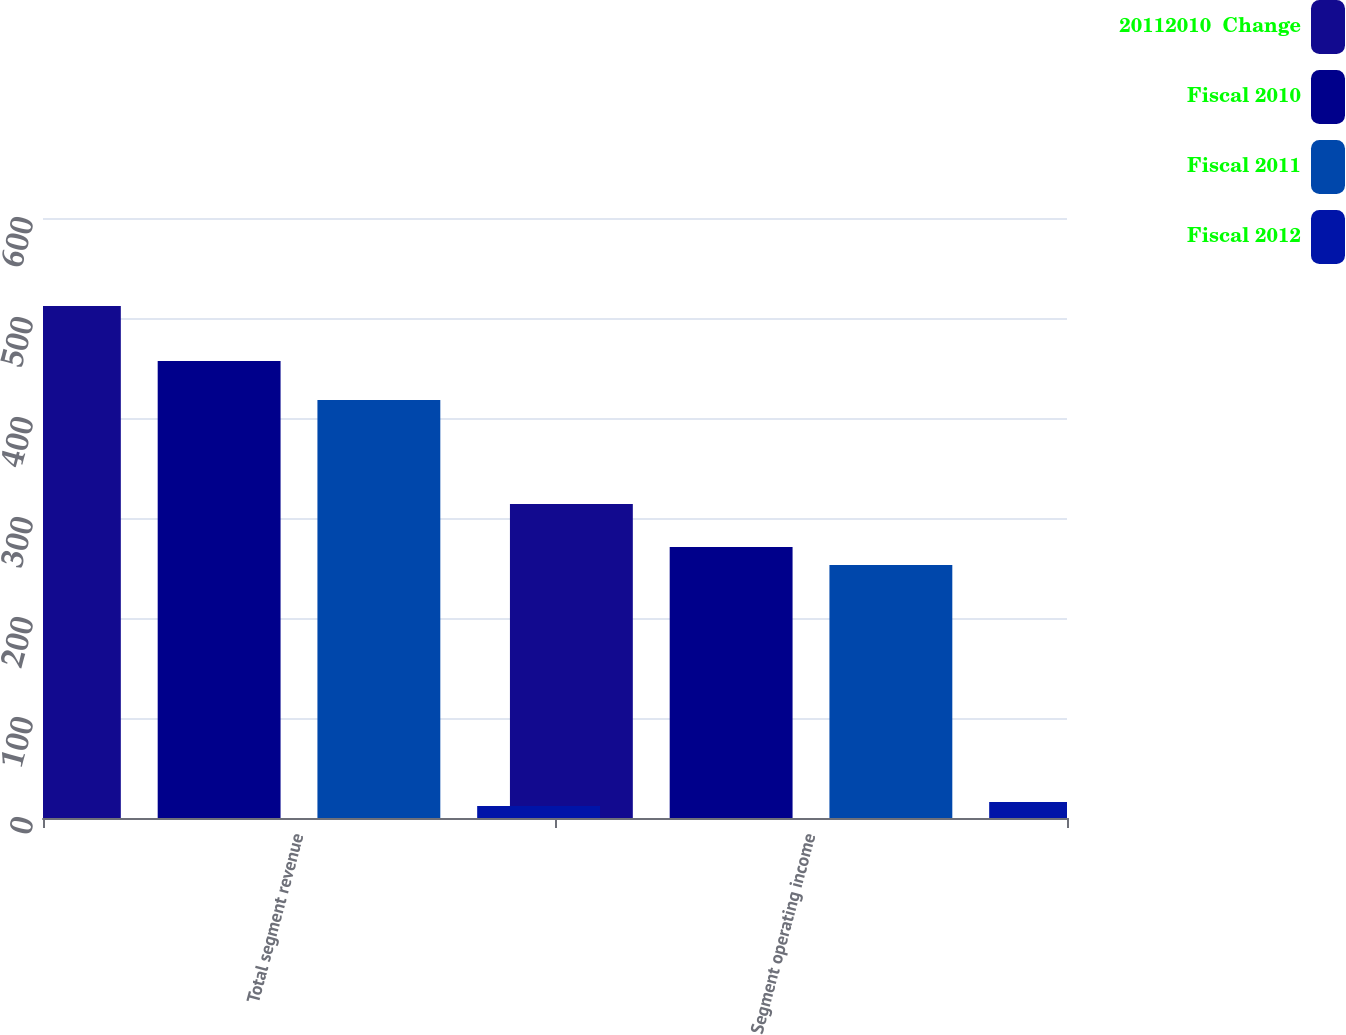Convert chart to OTSL. <chart><loc_0><loc_0><loc_500><loc_500><stacked_bar_chart><ecel><fcel>Total segment revenue<fcel>Segment operating income<nl><fcel>20112010  Change<fcel>512<fcel>314<nl><fcel>Fiscal 2010<fcel>457<fcel>271<nl><fcel>Fiscal 2011<fcel>418<fcel>253<nl><fcel>Fiscal 2012<fcel>12<fcel>16<nl></chart> 